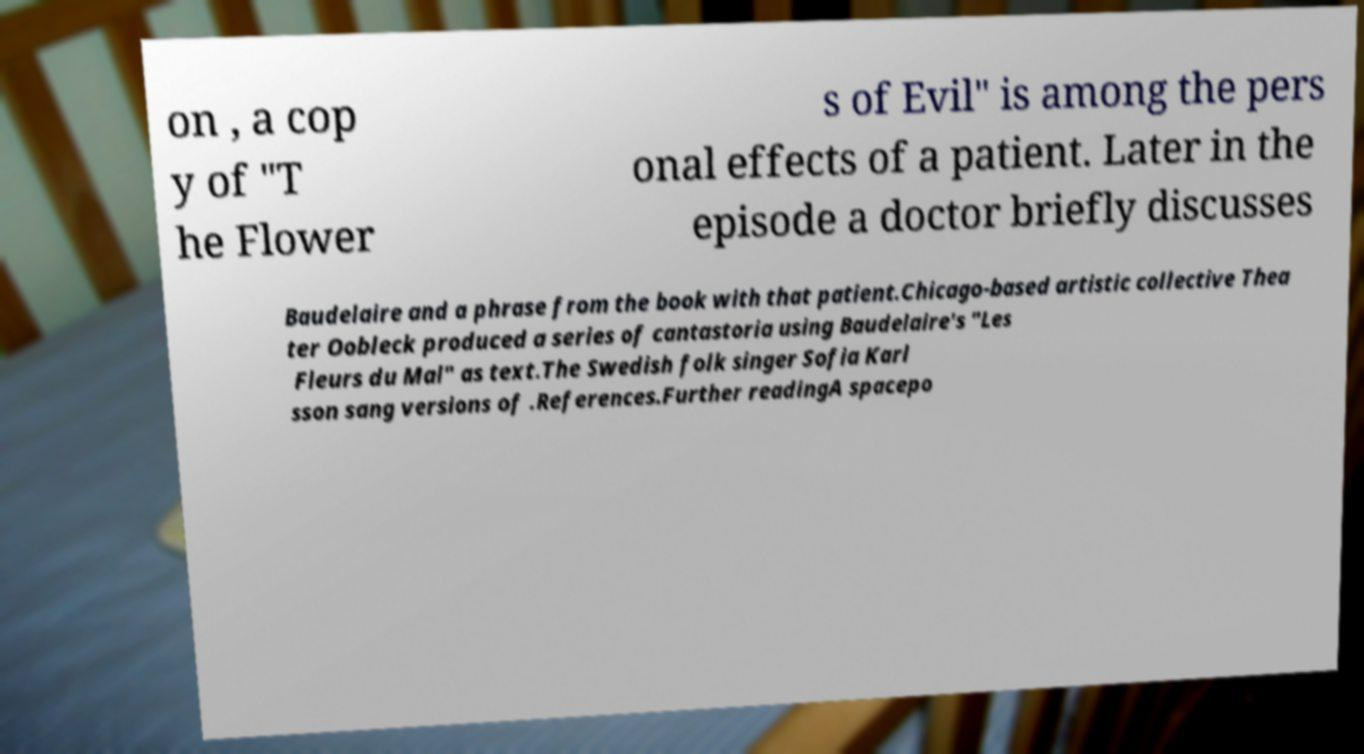I need the written content from this picture converted into text. Can you do that? on , a cop y of "T he Flower s of Evil" is among the pers onal effects of a patient. Later in the episode a doctor briefly discusses Baudelaire and a phrase from the book with that patient.Chicago-based artistic collective Thea ter Oobleck produced a series of cantastoria using Baudelaire's "Les Fleurs du Mal" as text.The Swedish folk singer Sofia Karl sson sang versions of .References.Further readingA spacepo 